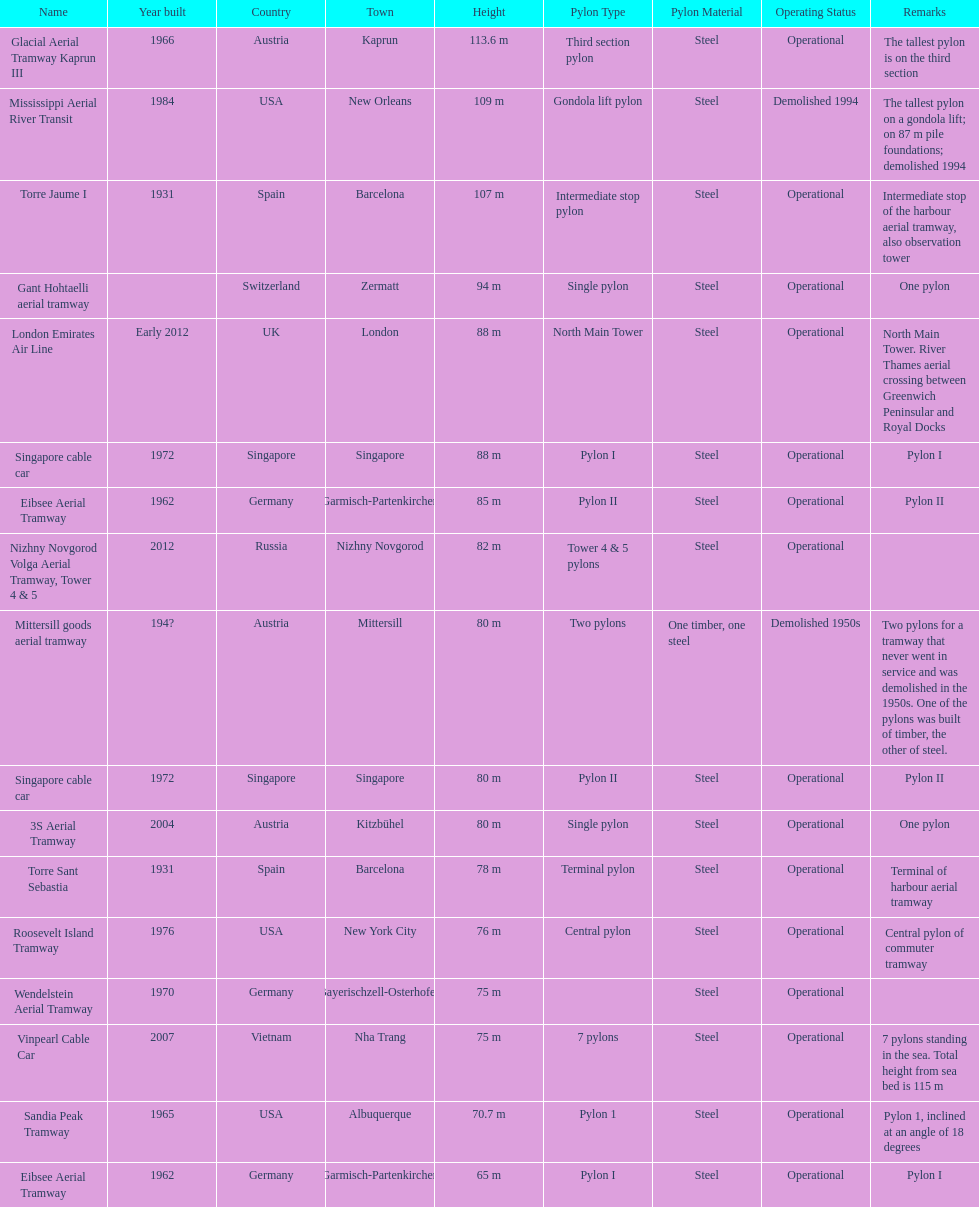Can you give me this table as a dict? {'header': ['Name', 'Year built', 'Country', 'Town', 'Height', 'Pylon Type', 'Pylon Material', 'Operating Status', 'Remarks'], 'rows': [['Glacial Aerial Tramway Kaprun III', '1966', 'Austria', 'Kaprun', '113.6 m', 'Third section pylon', 'Steel', 'Operational', 'The tallest pylon is on the third section'], ['Mississippi Aerial River Transit', '1984', 'USA', 'New Orleans', '109 m', 'Gondola lift pylon', 'Steel', 'Demolished 1994', 'The tallest pylon on a gondola lift; on 87 m pile foundations; demolished 1994'], ['Torre Jaume I', '1931', 'Spain', 'Barcelona', '107 m', 'Intermediate stop pylon', 'Steel', 'Operational', 'Intermediate stop of the harbour aerial tramway, also observation tower'], ['Gant Hohtaelli aerial tramway', '', 'Switzerland', 'Zermatt', '94 m', 'Single pylon', 'Steel', 'Operational', 'One pylon'], ['London Emirates Air Line', 'Early 2012', 'UK', 'London', '88 m', 'North Main Tower', 'Steel', 'Operational', 'North Main Tower. River Thames aerial crossing between Greenwich Peninsular and Royal Docks'], ['Singapore cable car', '1972', 'Singapore', 'Singapore', '88 m', 'Pylon I', 'Steel', 'Operational', 'Pylon I'], ['Eibsee Aerial Tramway', '1962', 'Germany', 'Garmisch-Partenkirchen', '85 m', 'Pylon II', 'Steel', 'Operational', 'Pylon II'], ['Nizhny Novgorod Volga Aerial Tramway, Tower 4 & 5', '2012', 'Russia', 'Nizhny Novgorod', '82 m', 'Tower 4 & 5 pylons', 'Steel', 'Operational', ''], ['Mittersill goods aerial tramway', '194?', 'Austria', 'Mittersill', '80 m', 'Two pylons', 'One timber, one steel', 'Demolished 1950s', 'Two pylons for a tramway that never went in service and was demolished in the 1950s. One of the pylons was built of timber, the other of steel.'], ['Singapore cable car', '1972', 'Singapore', 'Singapore', '80 m', 'Pylon II', 'Steel', 'Operational', 'Pylon II'], ['3S Aerial Tramway', '2004', 'Austria', 'Kitzbühel', '80 m', 'Single pylon', 'Steel', 'Operational', 'One pylon'], ['Torre Sant Sebastia', '1931', 'Spain', 'Barcelona', '78 m', 'Terminal pylon', 'Steel', 'Operational', 'Terminal of harbour aerial tramway'], ['Roosevelt Island Tramway', '1976', 'USA', 'New York City', '76 m', 'Central pylon', 'Steel', 'Operational', 'Central pylon of commuter tramway'], ['Wendelstein Aerial Tramway', '1970', 'Germany', 'Bayerischzell-Osterhofen', '75 m', '', 'Steel', 'Operational', ''], ['Vinpearl Cable Car', '2007', 'Vietnam', 'Nha Trang', '75 m', '7 pylons', 'Steel', 'Operational', '7 pylons standing in the sea. Total height from sea bed is 115 m'], ['Sandia Peak Tramway', '1965', 'USA', 'Albuquerque', '70.7 m', 'Pylon 1', 'Steel', 'Operational', 'Pylon 1, inclined at an angle of 18 degrees'], ['Eibsee Aerial Tramway', '1962', 'Germany', 'Garmisch-Partenkirchen', '65 m', 'Pylon I', 'Steel', 'Operational', 'Pylon I']]} The london emirates air line pylon has the same height as which pylon? Singapore cable car. 